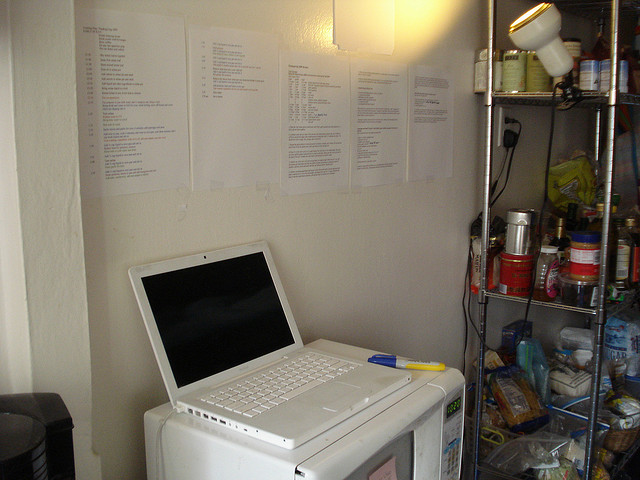Can you describe the main objects you see in the image? Certainly! The image features a white laptop situated on top of a microwave oven. Above the laptop, there are several pieces of paper affixed to a wall, likely containing notes or lists. To the right, a metal shelf holds various storage items including cans, jars, and a jar of honey. This area seems to be a multi-functional space, with elements of both a workspace and a storage area for food items. 